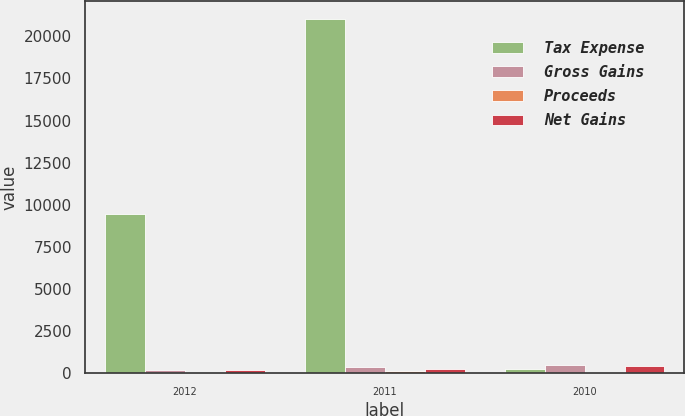<chart> <loc_0><loc_0><loc_500><loc_500><stacked_bar_chart><ecel><fcel>2012<fcel>2011<fcel>2010<nl><fcel>Tax Expense<fcel>9441<fcel>21039<fcel>249<nl><fcel>Gross Gains<fcel>214<fcel>406<fcel>490<nl><fcel>Proceeds<fcel>10<fcel>157<fcel>64<nl><fcel>Net Gains<fcel>204<fcel>249<fcel>426<nl></chart> 